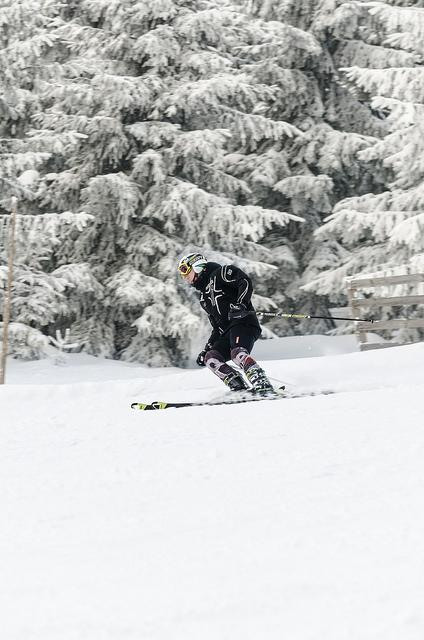Why do skiers wear suits?

Choices:
A) pilgrims
B) bikini
C) ski suit
D) snowsuit snowsuit 